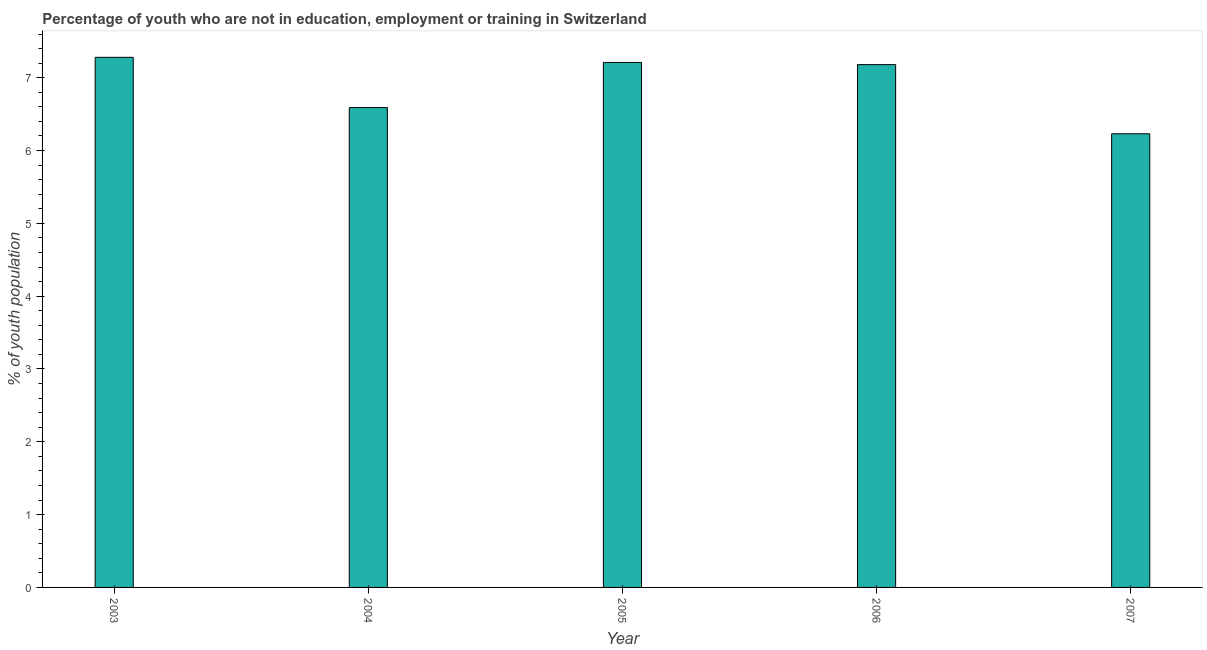What is the title of the graph?
Give a very brief answer. Percentage of youth who are not in education, employment or training in Switzerland. What is the label or title of the X-axis?
Provide a short and direct response. Year. What is the label or title of the Y-axis?
Your answer should be very brief. % of youth population. What is the unemployed youth population in 2006?
Provide a succinct answer. 7.18. Across all years, what is the maximum unemployed youth population?
Make the answer very short. 7.28. Across all years, what is the minimum unemployed youth population?
Keep it short and to the point. 6.23. What is the sum of the unemployed youth population?
Your response must be concise. 34.49. What is the average unemployed youth population per year?
Provide a short and direct response. 6.9. What is the median unemployed youth population?
Provide a short and direct response. 7.18. What is the ratio of the unemployed youth population in 2003 to that in 2006?
Offer a very short reply. 1.01. Is the unemployed youth population in 2004 less than that in 2005?
Give a very brief answer. Yes. Is the difference between the unemployed youth population in 2004 and 2007 greater than the difference between any two years?
Offer a terse response. No. What is the difference between the highest and the second highest unemployed youth population?
Provide a short and direct response. 0.07. How many years are there in the graph?
Offer a terse response. 5. What is the difference between two consecutive major ticks on the Y-axis?
Your answer should be compact. 1. Are the values on the major ticks of Y-axis written in scientific E-notation?
Your response must be concise. No. What is the % of youth population in 2003?
Ensure brevity in your answer.  7.28. What is the % of youth population in 2004?
Your response must be concise. 6.59. What is the % of youth population of 2005?
Provide a short and direct response. 7.21. What is the % of youth population of 2006?
Offer a very short reply. 7.18. What is the % of youth population in 2007?
Provide a succinct answer. 6.23. What is the difference between the % of youth population in 2003 and 2004?
Offer a terse response. 0.69. What is the difference between the % of youth population in 2003 and 2005?
Ensure brevity in your answer.  0.07. What is the difference between the % of youth population in 2003 and 2006?
Offer a terse response. 0.1. What is the difference between the % of youth population in 2003 and 2007?
Ensure brevity in your answer.  1.05. What is the difference between the % of youth population in 2004 and 2005?
Ensure brevity in your answer.  -0.62. What is the difference between the % of youth population in 2004 and 2006?
Provide a succinct answer. -0.59. What is the difference between the % of youth population in 2004 and 2007?
Make the answer very short. 0.36. What is the difference between the % of youth population in 2005 and 2006?
Your response must be concise. 0.03. What is the difference between the % of youth population in 2005 and 2007?
Your answer should be compact. 0.98. What is the difference between the % of youth population in 2006 and 2007?
Ensure brevity in your answer.  0.95. What is the ratio of the % of youth population in 2003 to that in 2004?
Provide a succinct answer. 1.1. What is the ratio of the % of youth population in 2003 to that in 2007?
Make the answer very short. 1.17. What is the ratio of the % of youth population in 2004 to that in 2005?
Make the answer very short. 0.91. What is the ratio of the % of youth population in 2004 to that in 2006?
Provide a short and direct response. 0.92. What is the ratio of the % of youth population in 2004 to that in 2007?
Offer a terse response. 1.06. What is the ratio of the % of youth population in 2005 to that in 2006?
Ensure brevity in your answer.  1. What is the ratio of the % of youth population in 2005 to that in 2007?
Your answer should be very brief. 1.16. What is the ratio of the % of youth population in 2006 to that in 2007?
Provide a short and direct response. 1.15. 